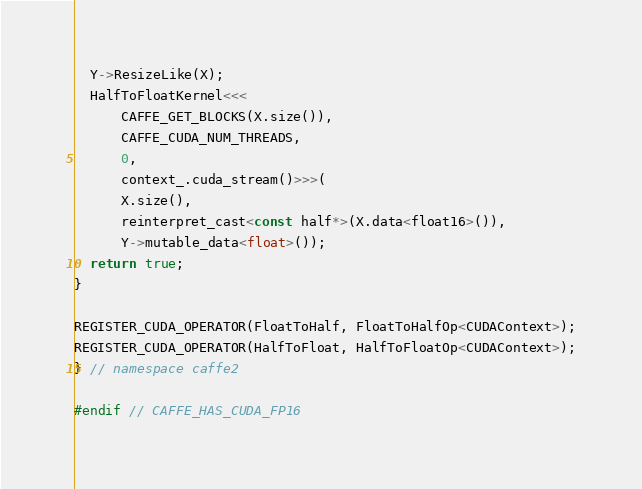<code> <loc_0><loc_0><loc_500><loc_500><_Cuda_>  Y->ResizeLike(X);
  HalfToFloatKernel<<<
      CAFFE_GET_BLOCKS(X.size()),
      CAFFE_CUDA_NUM_THREADS,
      0,
      context_.cuda_stream()>>>(
      X.size(),
      reinterpret_cast<const half*>(X.data<float16>()),
      Y->mutable_data<float>());
  return true;
}

REGISTER_CUDA_OPERATOR(FloatToHalf, FloatToHalfOp<CUDAContext>);
REGISTER_CUDA_OPERATOR(HalfToFloat, HalfToFloatOp<CUDAContext>);
} // namespace caffe2

#endif // CAFFE_HAS_CUDA_FP16
</code> 